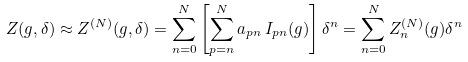Convert formula to latex. <formula><loc_0><loc_0><loc_500><loc_500>Z ( g , \delta ) \approx Z ^ { ( N ) } ( g , \delta ) = \sum _ { n = 0 } ^ { N } \left [ \sum _ { p = n } ^ { N } a _ { p n } \, I _ { p n } ( g ) \right ] { \delta } ^ { n } = \sum _ { n = 0 } ^ { N } Z ^ { ( N ) } _ { n } ( g ) { \delta } ^ { n }</formula> 